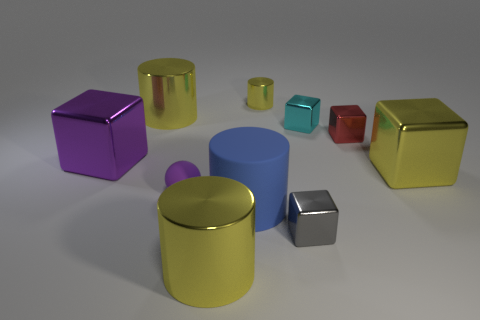There is a large cylinder that is to the right of the large yellow thing in front of the big object that is to the right of the red shiny cube; what is its color?
Your answer should be compact. Blue. There is a large metallic thing that is to the right of the tiny cyan object; is it the same shape as the gray object?
Provide a short and direct response. Yes. How many large cylinders are there?
Provide a short and direct response. 3. What number of gray metallic cubes are the same size as the red cube?
Make the answer very short. 1. What is the material of the small purple ball?
Your answer should be very brief. Rubber. There is a ball; is it the same color as the big metallic cube on the right side of the tiny cyan thing?
Give a very brief answer. No. Is there any other thing that is the same size as the red cube?
Keep it short and to the point. Yes. There is a yellow object that is left of the red metallic cube and in front of the red metallic thing; what size is it?
Provide a succinct answer. Large. There is a gray thing that is made of the same material as the small yellow object; what shape is it?
Provide a succinct answer. Cube. Is the material of the blue object the same as the large cylinder that is in front of the blue rubber cylinder?
Give a very brief answer. No. 